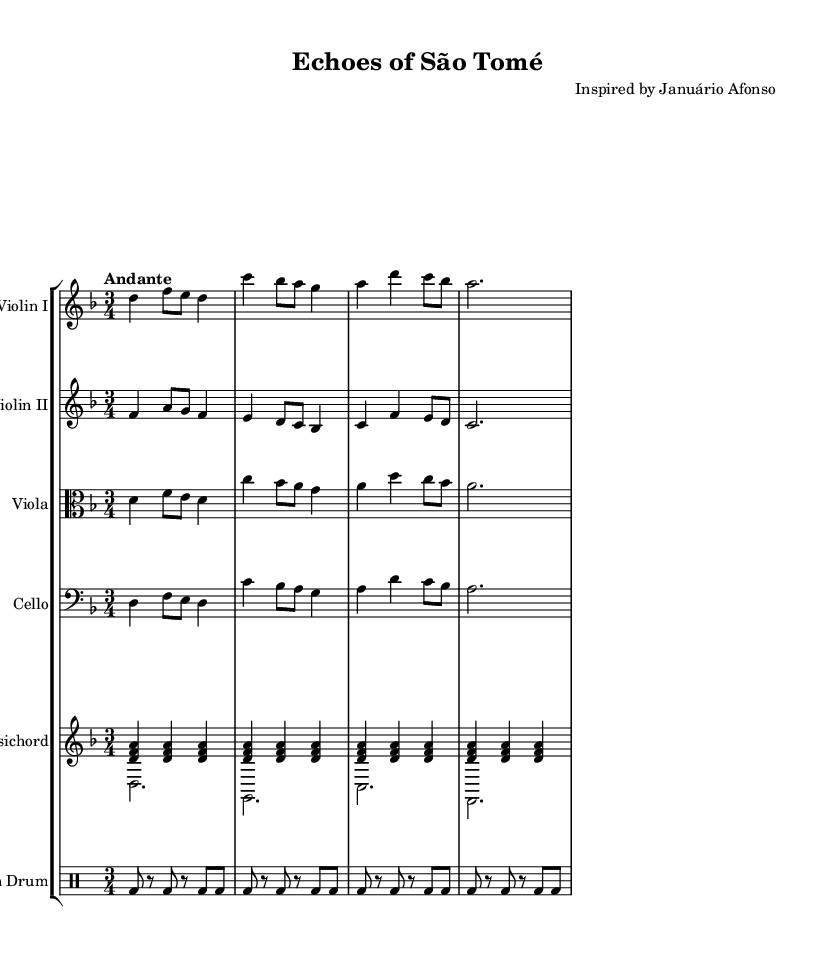What is the time signature of this music? The time signature is indicated at the beginning of the sheet music as 3/4, which means there are three beats in each measure and a quarter note receives one beat.
Answer: 3/4 What is the key signature of this music? The key signature is indicated by the one flat in the clef, which corresponds to D minor, as D minor has one flat (B flat).
Answer: D minor What is the tempo marking of this piece? The tempo marking "Andante" is located near the beginning of the sheet music, indicating a moderately slow tempo.
Answer: Andante How many different instruments are included in the score? By counting the staves in the score, which include Violin I, Violin II, Viola, Cello, Harpsichord, and African Drum, we find a total of six distinct instruments.
Answer: 6 Which instrument plays the african drum part? The DrumStaff labeled "African Drum" clearly indicates that the percussion part is designated for the African Drum.
Answer: African Drum What is the rhythmic pattern of the African Drum? The rhythmic pattern is indicated in the drumming notation, showing a steady alternating pattern of bass drum hits on the beats, with rests placed in between.
Answer: alternating bass drum pattern What stylistic elements suggest this piece is in the Baroque style? This piece employs distinct characteristics of the Baroque era, such as a clear melodic line, ornamental figures in the violin parts, and the drone-like qualities found in the harpsichord accompaniment.
Answer: melodic lines and ornamentation 